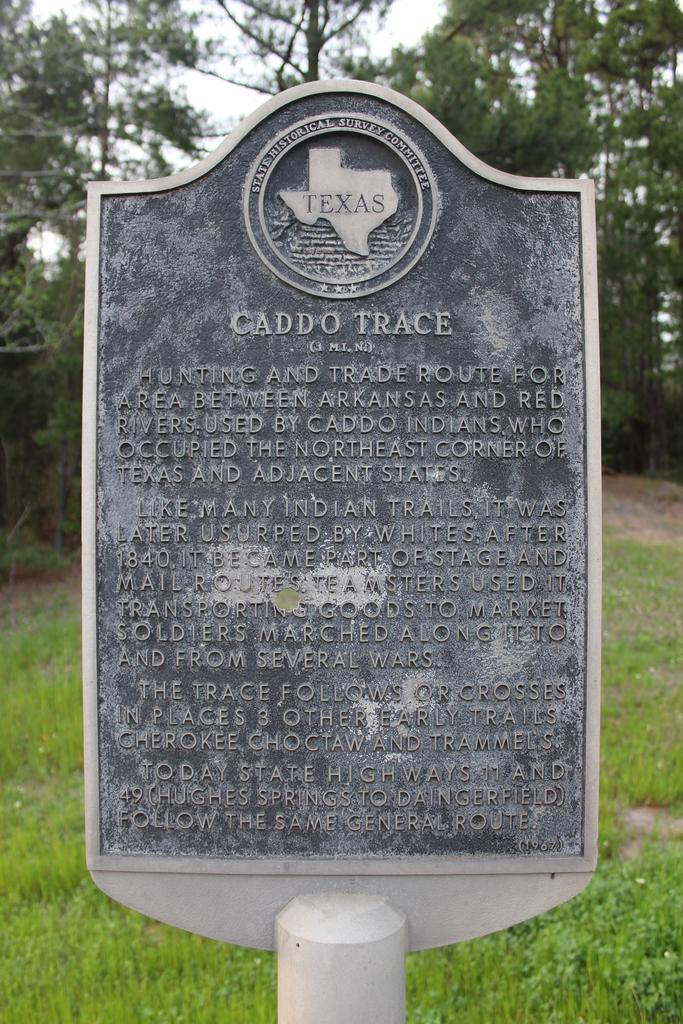What is on the board that is visible in the image? There is text on the board in the image. What can be seen in the distance in the image? There are trees in the background of the image. What type of vegetation is on the ground in the image? There is grass on the ground in the image. What type of machine is being used to apply wax to the canvas in the image? There is no machine, wax, or canvas present in the image. 